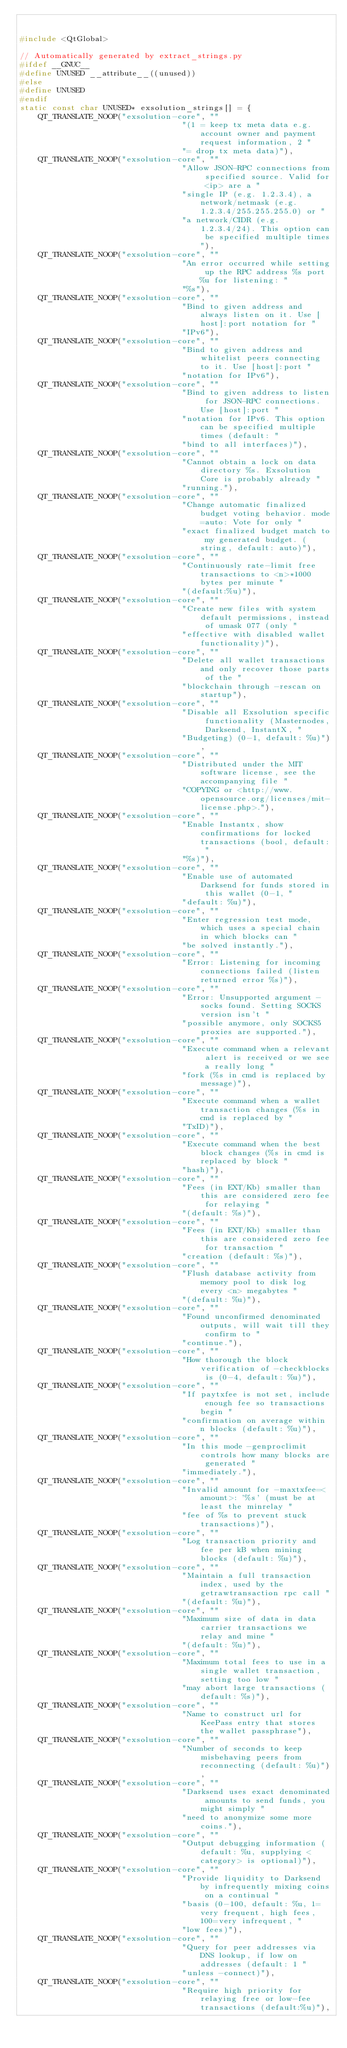<code> <loc_0><loc_0><loc_500><loc_500><_C++_>

#include <QtGlobal>

// Automatically generated by extract_strings.py
#ifdef __GNUC__
#define UNUSED __attribute__((unused))
#else
#define UNUSED
#endif
static const char UNUSED* exsolution_strings[] = {
    QT_TRANSLATE_NOOP("exsolution-core", ""
                                   "(1 = keep tx meta data e.g. account owner and payment request information, 2 "
                                   "= drop tx meta data)"),
    QT_TRANSLATE_NOOP("exsolution-core", ""
                                   "Allow JSON-RPC connections from specified source. Valid for <ip> are a "
                                   "single IP (e.g. 1.2.3.4), a network/netmask (e.g. 1.2.3.4/255.255.255.0) or "
                                   "a network/CIDR (e.g. 1.2.3.4/24). This option can be specified multiple times"),
    QT_TRANSLATE_NOOP("exsolution-core", ""
                                   "An error occurred while setting up the RPC address %s port %u for listening: "
                                   "%s"),
    QT_TRANSLATE_NOOP("exsolution-core", ""
                                   "Bind to given address and always listen on it. Use [host]:port notation for "
                                   "IPv6"),
    QT_TRANSLATE_NOOP("exsolution-core", ""
                                   "Bind to given address and whitelist peers connecting to it. Use [host]:port "
                                   "notation for IPv6"),
    QT_TRANSLATE_NOOP("exsolution-core", ""
                                   "Bind to given address to listen for JSON-RPC connections. Use [host]:port "
                                   "notation for IPv6. This option can be specified multiple times (default: "
                                   "bind to all interfaces)"),
    QT_TRANSLATE_NOOP("exsolution-core", ""
                                   "Cannot obtain a lock on data directory %s. Exsolution Core is probably already "
                                   "running."),
    QT_TRANSLATE_NOOP("exsolution-core", ""
                                   "Change automatic finalized budget voting behavior. mode=auto: Vote for only "
                                   "exact finalized budget match to my generated budget. (string, default: auto)"),
    QT_TRANSLATE_NOOP("exsolution-core", ""
                                   "Continuously rate-limit free transactions to <n>*1000 bytes per minute "
                                   "(default:%u)"),
    QT_TRANSLATE_NOOP("exsolution-core", ""
                                   "Create new files with system default permissions, instead of umask 077 (only "
                                   "effective with disabled wallet functionality)"),
    QT_TRANSLATE_NOOP("exsolution-core", ""
                                   "Delete all wallet transactions and only recover those parts of the "
                                   "blockchain through -rescan on startup"),
    QT_TRANSLATE_NOOP("exsolution-core", ""
                                   "Disable all Exsolution specific functionality (Masternodes, Darksend, InstantX, "
                                   "Budgeting) (0-1, default: %u)"),
    QT_TRANSLATE_NOOP("exsolution-core", ""
                                   "Distributed under the MIT software license, see the accompanying file "
                                   "COPYING or <http://www.opensource.org/licenses/mit-license.php>."),
    QT_TRANSLATE_NOOP("exsolution-core", ""
                                   "Enable Instantx, show confirmations for locked transactions (bool, default: "
                                   "%s)"),
    QT_TRANSLATE_NOOP("exsolution-core", ""
                                   "Enable use of automated Darksend for funds stored in this wallet (0-1, "
                                   "default: %u)"),
    QT_TRANSLATE_NOOP("exsolution-core", ""
                                   "Enter regression test mode, which uses a special chain in which blocks can "
                                   "be solved instantly."),
    QT_TRANSLATE_NOOP("exsolution-core", ""
                                   "Error: Listening for incoming connections failed (listen returned error %s)"),
    QT_TRANSLATE_NOOP("exsolution-core", ""
                                   "Error: Unsupported argument -socks found. Setting SOCKS version isn't "
                                   "possible anymore, only SOCKS5 proxies are supported."),
    QT_TRANSLATE_NOOP("exsolution-core", ""
                                   "Execute command when a relevant alert is received or we see a really long "
                                   "fork (%s in cmd is replaced by message)"),
    QT_TRANSLATE_NOOP("exsolution-core", ""
                                   "Execute command when a wallet transaction changes (%s in cmd is replaced by "
                                   "TxID)"),
    QT_TRANSLATE_NOOP("exsolution-core", ""
                                   "Execute command when the best block changes (%s in cmd is replaced by block "
                                   "hash)"),
    QT_TRANSLATE_NOOP("exsolution-core", ""
                                   "Fees (in EXT/Kb) smaller than this are considered zero fee for relaying "
                                   "(default: %s)"),
    QT_TRANSLATE_NOOP("exsolution-core", ""
                                   "Fees (in EXT/Kb) smaller than this are considered zero fee for transaction "
                                   "creation (default: %s)"),
    QT_TRANSLATE_NOOP("exsolution-core", ""
                                   "Flush database activity from memory pool to disk log every <n> megabytes "
                                   "(default: %u)"),
    QT_TRANSLATE_NOOP("exsolution-core", ""
                                   "Found unconfirmed denominated outputs, will wait till they confirm to "
                                   "continue."),
    QT_TRANSLATE_NOOP("exsolution-core", ""
                                   "How thorough the block verification of -checkblocks is (0-4, default: %u)"),
    QT_TRANSLATE_NOOP("exsolution-core", ""
                                   "If paytxfee is not set, include enough fee so transactions begin "
                                   "confirmation on average within n blocks (default: %u)"),
    QT_TRANSLATE_NOOP("exsolution-core", ""
                                   "In this mode -genproclimit controls how many blocks are generated "
                                   "immediately."),
    QT_TRANSLATE_NOOP("exsolution-core", ""
                                   "Invalid amount for -maxtxfee=<amount>: '%s' (must be at least the minrelay "
                                   "fee of %s to prevent stuck transactions)"),
    QT_TRANSLATE_NOOP("exsolution-core", ""
                                   "Log transaction priority and fee per kB when mining blocks (default: %u)"),
    QT_TRANSLATE_NOOP("exsolution-core", ""
                                   "Maintain a full transaction index, used by the getrawtransaction rpc call "
                                   "(default: %u)"),
    QT_TRANSLATE_NOOP("exsolution-core", ""
                                   "Maximum size of data in data carrier transactions we relay and mine "
                                   "(default: %u)"),
    QT_TRANSLATE_NOOP("exsolution-core", ""
                                   "Maximum total fees to use in a single wallet transaction, setting too low "
                                   "may abort large transactions (default: %s)"),
    QT_TRANSLATE_NOOP("exsolution-core", ""
                                   "Name to construct url for KeePass entry that stores the wallet passphrase"),
    QT_TRANSLATE_NOOP("exsolution-core", ""
                                   "Number of seconds to keep misbehaving peers from reconnecting (default: %u)"),
    QT_TRANSLATE_NOOP("exsolution-core", ""
                                   "Darksend uses exact denominated amounts to send funds, you might simply "
                                   "need to anonymize some more coins."),
    QT_TRANSLATE_NOOP("exsolution-core", ""
                                   "Output debugging information (default: %u, supplying <category> is optional)"),
    QT_TRANSLATE_NOOP("exsolution-core", ""
                                   "Provide liquidity to Darksend by infrequently mixing coins on a continual "
                                   "basis (0-100, default: %u, 1=very frequent, high fees, 100=very infrequent, "
                                   "low fees)"),
    QT_TRANSLATE_NOOP("exsolution-core", ""
                                   "Query for peer addresses via DNS lookup, if low on addresses (default: 1 "
                                   "unless -connect)"),
    QT_TRANSLATE_NOOP("exsolution-core", ""
                                   "Require high priority for relaying free or low-fee transactions (default:%u)"),</code> 